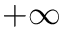Convert formula to latex. <formula><loc_0><loc_0><loc_500><loc_500>+ \infty</formula> 